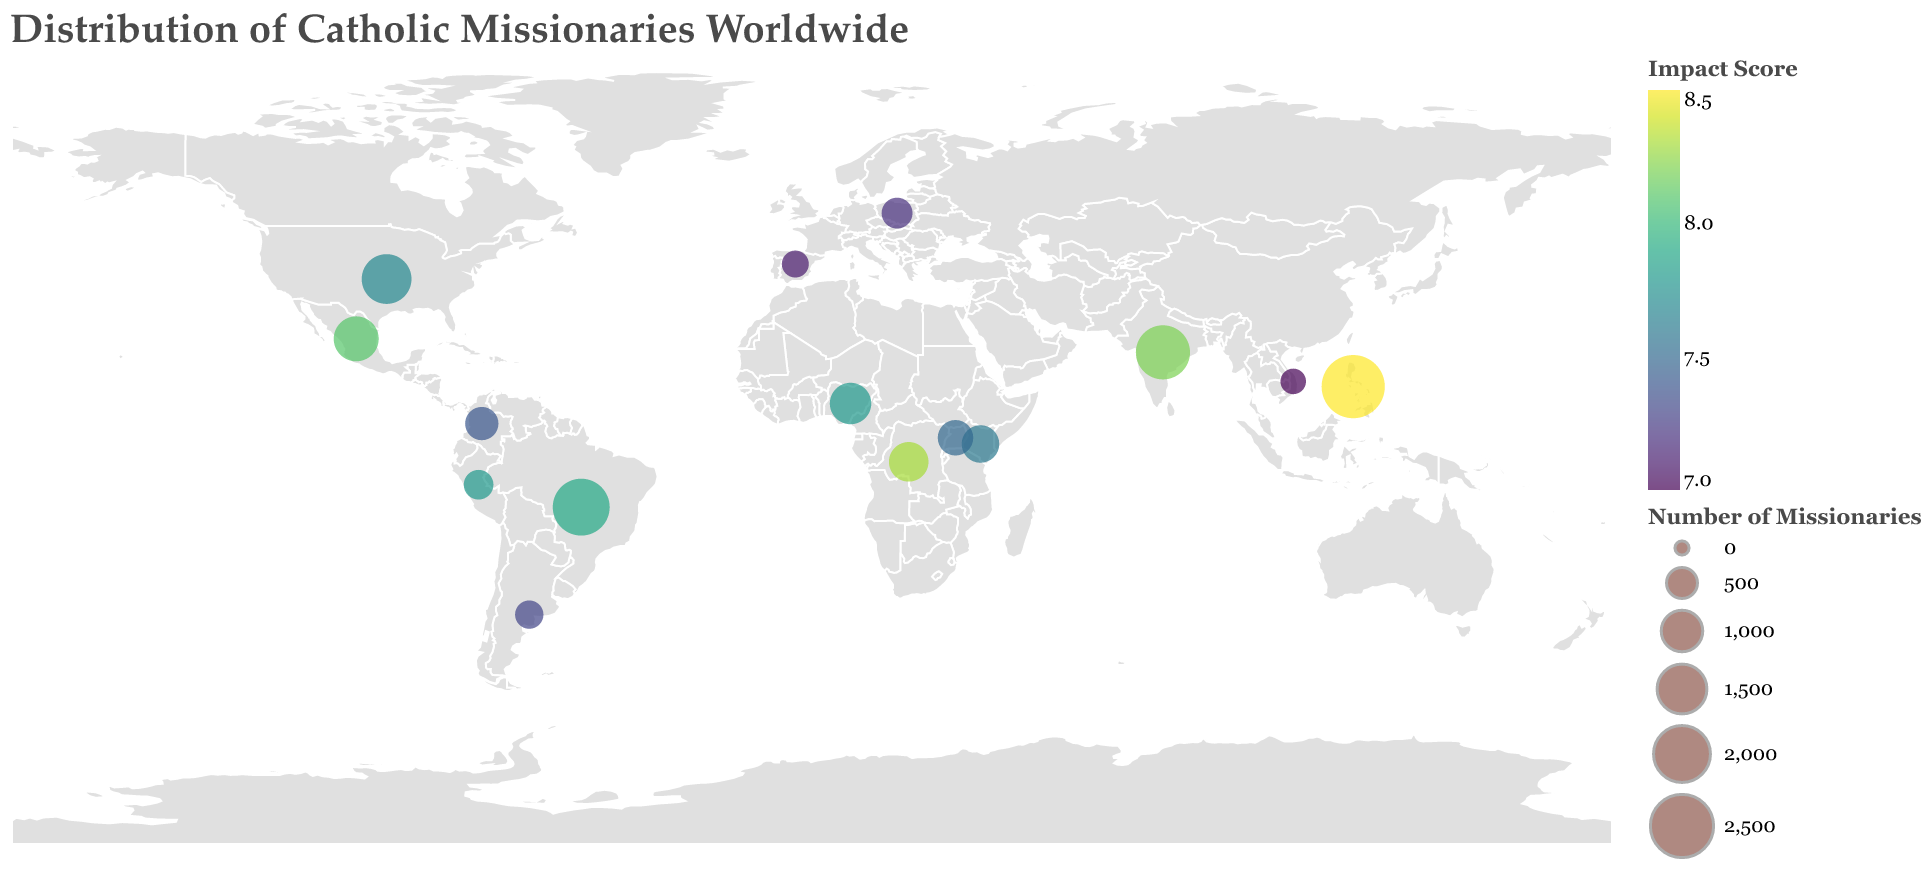How many missionaries are there in the United States? The United States has a circle representing its missionaries. By looking at the tooltip or legend that details the number of missionaries per circle, it's labeled as having 1500 missionaries.
Answer: 1500 Which country has the highest number of missionaries and what is their focus area? The largest circle on the plot indicates the highest number of missionaries, located in the Philippines. According to the tooltip associated with this circle, the focus area is Education.
Answer: Philippines, Education What is the impact score of missionaries in Brazil? By examining the circle representing Brazil and its tooltip, it shows an impact score of 7.9.
Answer: 7.9 Compare the impact scores of India and Mexico. Which one is higher? By checking the circles in India and Mexico and their respective tooltips, India's impact score is 8.2 while Mexico's is 8.1. Thus, India has a higher impact score.
Answer: India What is the average number of missionaries across all the countries listed? Sum the number of missionaries from all countries (2500 + 2000 + 1800 + 1500 + 1200 + 1000 + 900 + 800 + 700 + 600 + 500 + 450 + 400 + 350 + 300) = 15000. Then divide this by the number of countries (15) to find the average, which is 15000/15 = 1000.
Answer: 1000 Which country has the lowest impact score and what is it focused on? The plot shows the different impact scores, and the lowest impact score is found to be in Vietnam, which is 7.0. The focus area for Vietnam is Interfaith Dialogue.
Answer: Vietnam, Interfaith Dialogue What is the total impact score for the African countries listed (Nigeria, Democratic Republic of Congo, Kenya, and Uganda)? Sum the impact scores for the listed African countries from their respective circles: Nigeria (7.8) + Democratic Republic of Congo (8.3) + Kenya (7.6) + Uganda (7.5) = 31.2.
Answer: 31.2 How does the number of missionaries in Brazil compare to those in the Democratic Republic of Congo? Brazil has 2000 missionaries while the Democratic Republic of Congo has 900, so Brazil has more missionaries.
Answer: Brazil has more Find the country with the smallest circle and state its number of missionaries and focus area. The smallest circle represents Vietnam, which has 300 missionaries and focuses on Interfaith Dialogue, indicated by the tooltip.
Answer: Vietnam, 300, Interfaith Dialogue 